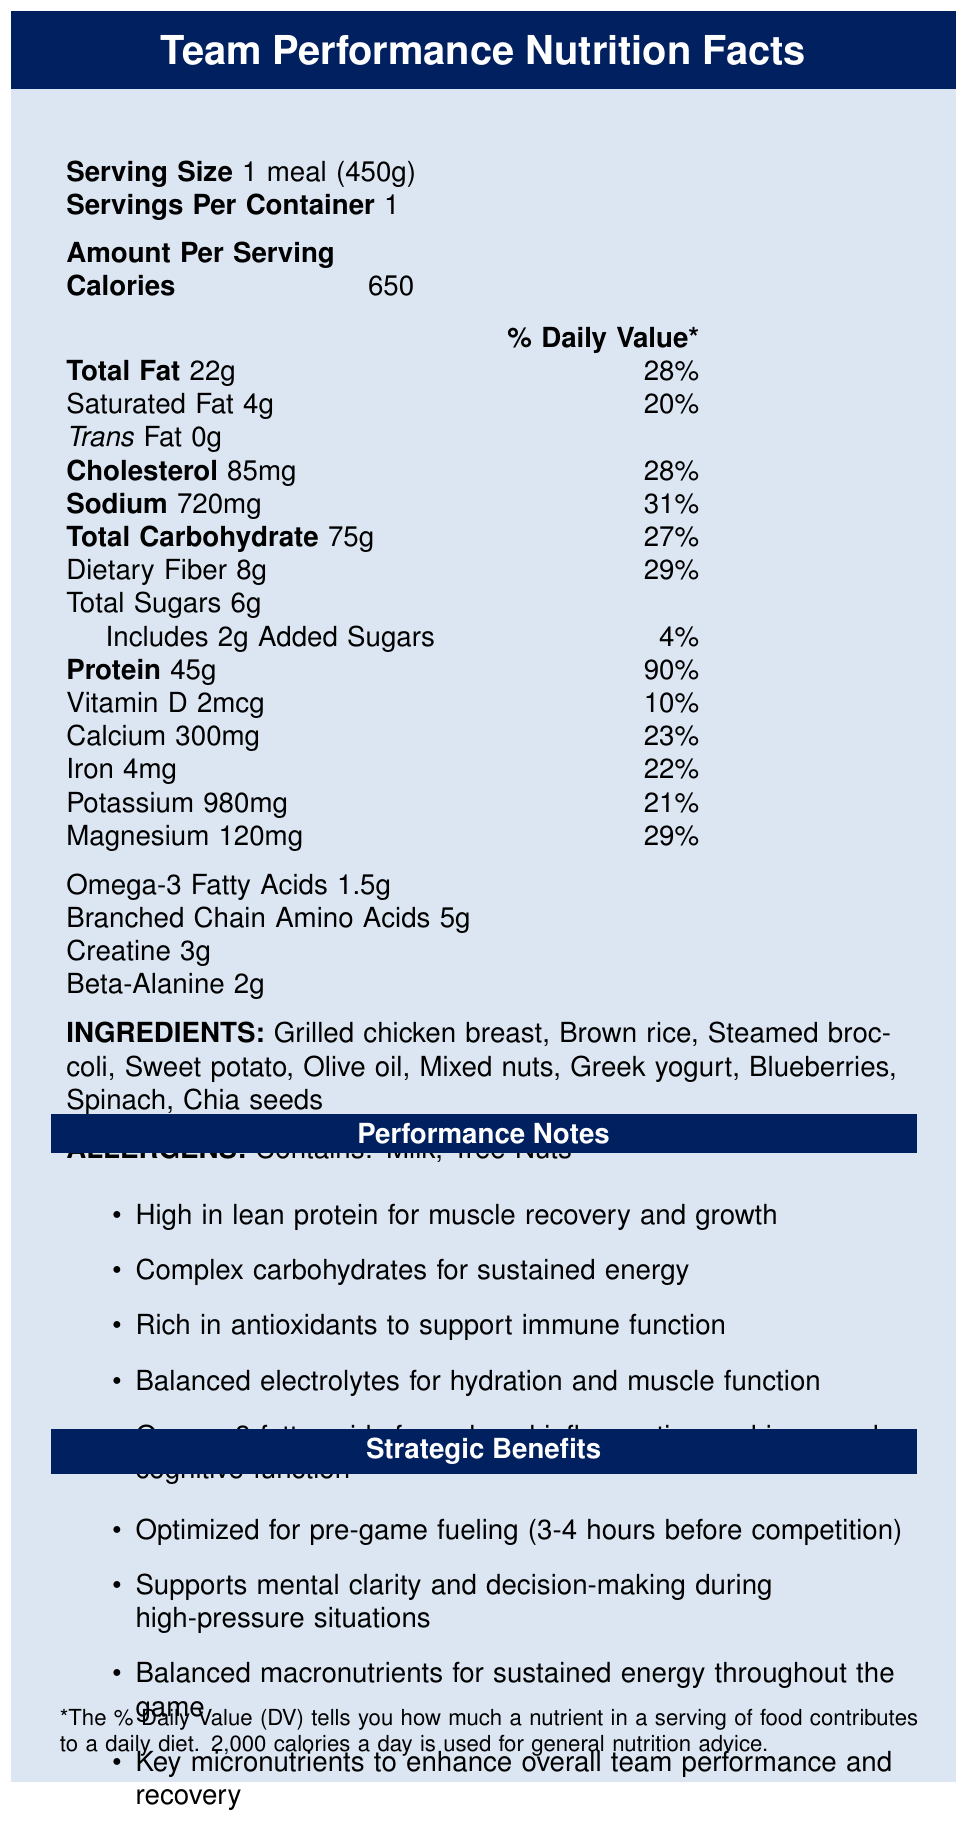what is the serving size of the meal? The serving size is clearly mentioned at the top of the nutrition facts section as "1 meal (450g)".
Answer: 1 meal (450g) how many calories are in one serving of the meal? The calories per serving are listed as 650 in the document.
Answer: 650 what are the total fat and saturated fat contents in this meal? The total fat content is 22g and the saturated fat content is 4g, both listed clearly in the table of amounts per serving.
Answer: Total Fat: 22g, Saturated Fat: 4g how much protein does this meal provide per serving? The protein content per serving is highlighted as 45g in the document.
Answer: 45g which vitamins and minerals are present in this meal with their respective amounts? The document lists the amounts for Vitamin D, Calcium, Iron, Potassium, and Magnesium in the nutrition facts section.
Answer: Vitamin D: 2mcg, Calcium: 300mg, Iron: 4mg, Potassium: 980mg, Magnesium: 120mg what percentage of the daily value of sodium does this meal contain? The percentage daily value for sodium is mentioned as 31% in the nutrition facts section.
Answer: 31% how much dietary fiber is in one serving of this meal? The dietary fiber content is listed as 8g per serving.
Answer: 8g which of the following is a noted performance benefit of this meal? A. Low in protein B. High in antioxidants C. Low in carbohydrates D. Low in sodium The document mentions that the meal is rich in antioxidants to support immune function.
Answer: B which macronutrient is this meal the highest in? A. Protein B. Total Carbohydrates C. Total Fat D. Dietary Fiber The meal is highest in protein with 45g per serving, compared to 75g carbohydrates, 22g fat, and 8g fiber.
Answer: A does this meal contain any allergens? The document states that the meal contains milk and tree nuts as allergens.
Answer: Yes what are some of the strategic benefits of this meal according to the document? These strategic benefits are described in the "Strategic Benefits" section of the document.
Answer: The meal is optimized for pre-game fueling, supports mental clarity and decision-making, has balanced macronutrients for sustained energy, and includes key micronutrients to enhance performance and recovery. is this meal optimized for post-game recovery? The document specifically mentions that the meal is "optimized for pre-game fueling (3-4 hours before competition)", not post-game recovery.
Answer: No list all the ingredients used in this meal. The ingredients list specifies these items clearly in the document.
Answer: Grilled chicken breast, Brown rice, Steamed broccoli, Sweet potato, Olive oil, Mixed nuts, Greek yogurt, Blueberries, Spinach, Chia seeds briefly summarize the main benefits of this nutrition meal for a sports team The main benefits are outlined under the "Performance Notes" and "Strategic Benefits" sections in the document.
Answer: The meal provides balanced macronutrients for sustained energy, high protein for muscle recovery and growth, antioxidants to support immune function, and key micronutrients to enhance overall performance and recovery. how much creatine and beta-alanine are included in this meal? These amounts are listed at the bottom of the nutrition facts section.
Answer: Creatine: 3g, Beta-Alanine: 2g how many calories from fat are in this meal? The document lists the total calories and total fat content, but does not provide the breakdown of calories specifically from fat.
Answer: Cannot be determined what is the total carbohydrate content including dietary fiber and total sugars in this meal? The document specifies these amounts in the nutrition facts.
Answer: Total Carbohydrate: 75g, Dietary Fiber: 8g, Total Sugars: 6g, Added Sugars: 2g 